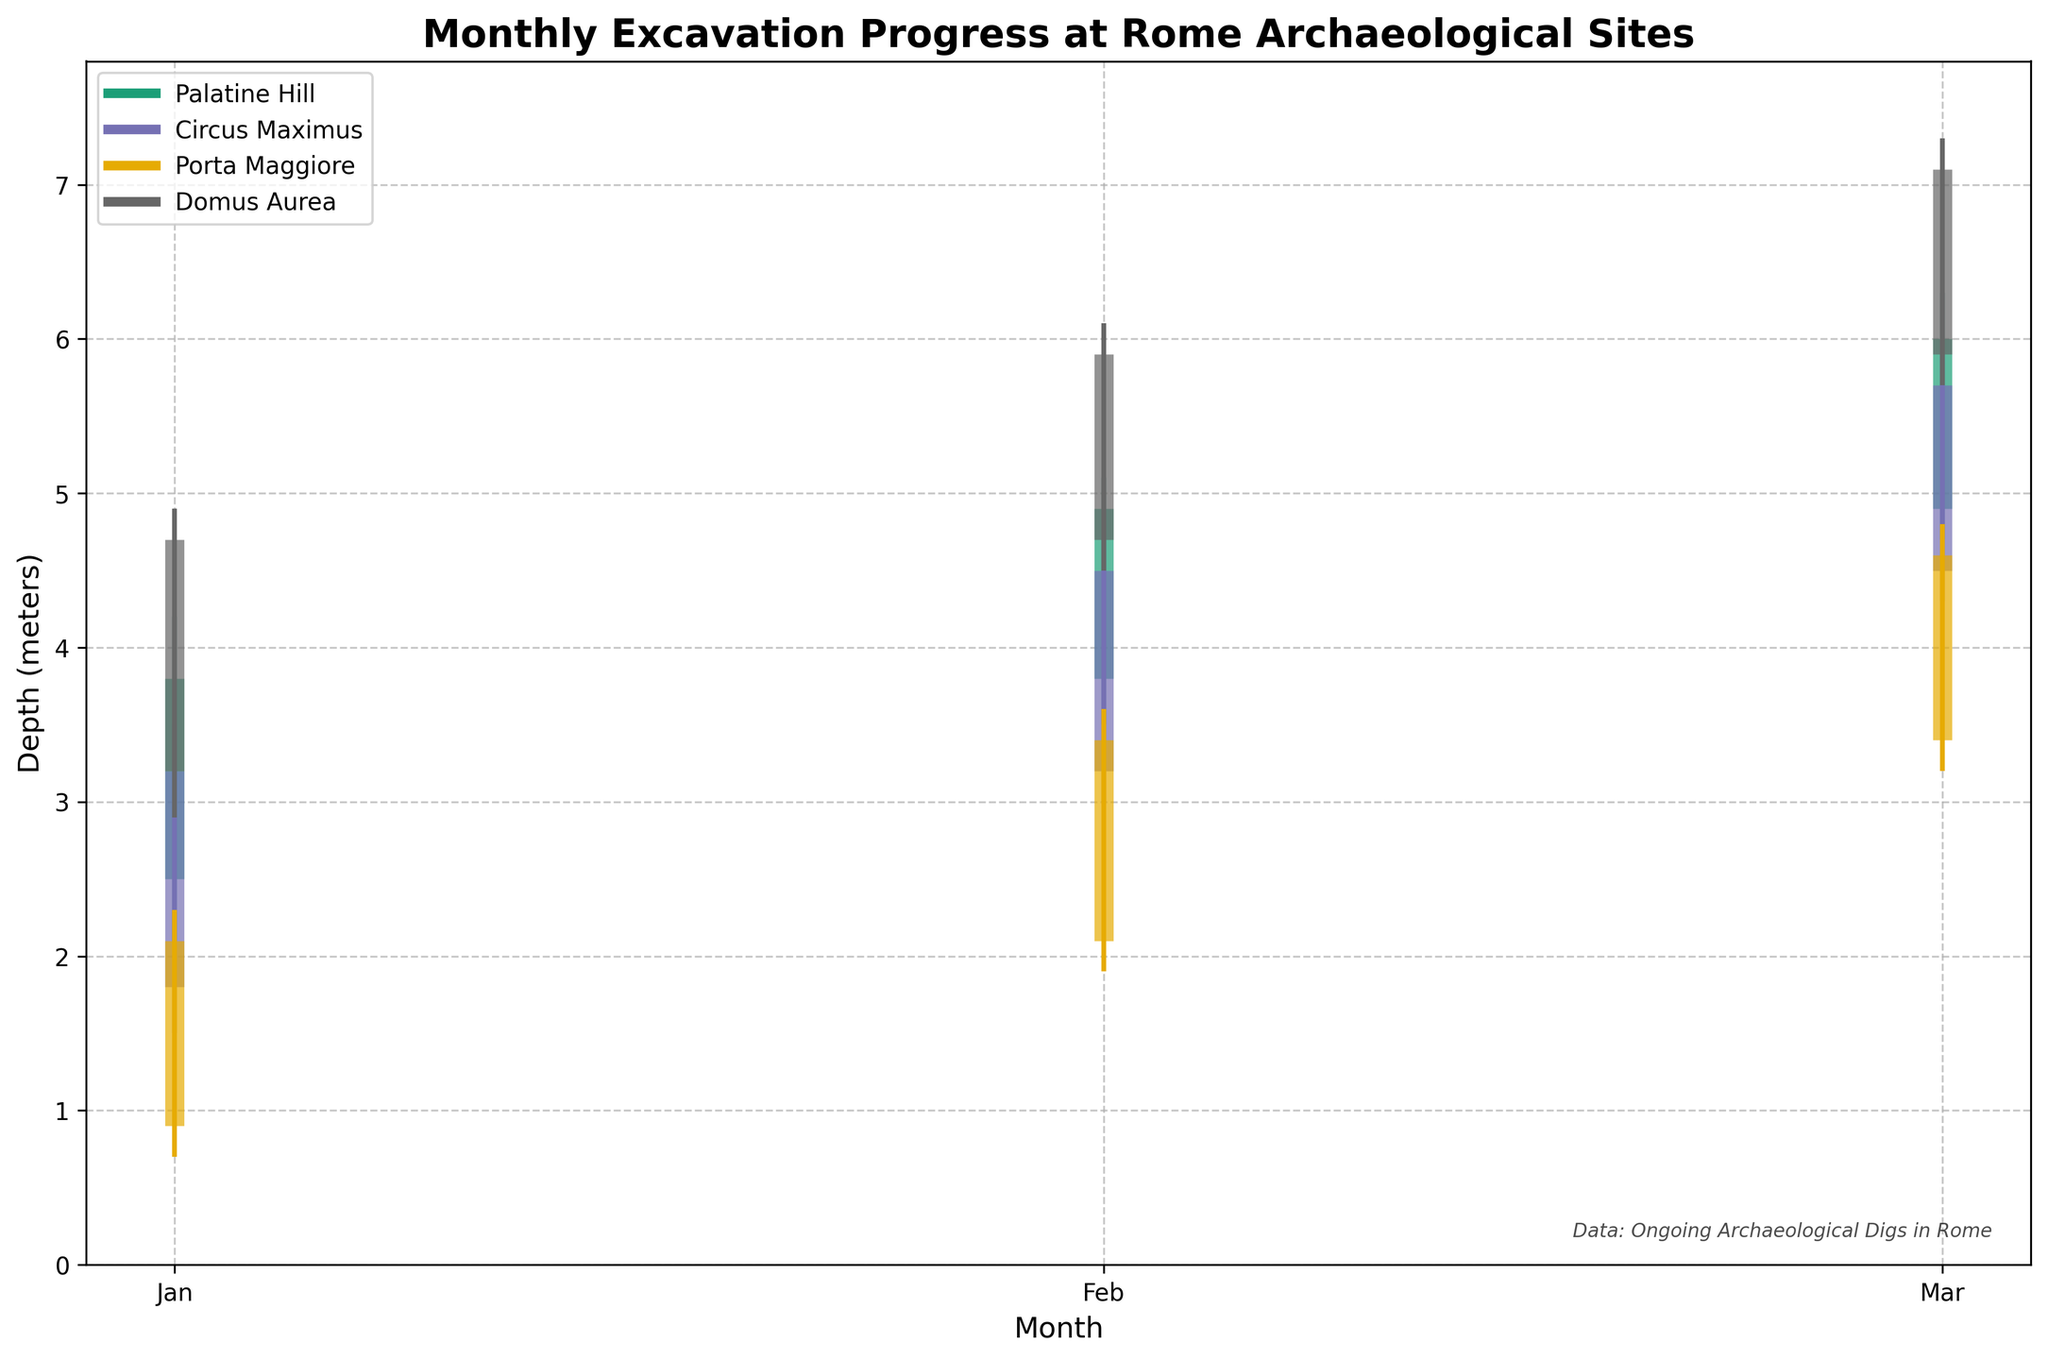What's the title of the plot? The title is usually displayed prominently at the top of the plot. The title of this plot is "Monthly Excavation Progress at Rome Archaeological Sites".
Answer: Monthly Excavation Progress at Rome Archaeological Sites What does the x-axis represent? The x-axis typically represents a variable that changes over time or across different categories. In this plot, the x-axis represents the months of the year.
Answer: Months What does the y-axis represent? The y-axis usually represents the variable being measured. In this plot, the y-axis represents depth in meters.
Answer: Depth (meters) Which site reached the maximum depth in March? To find this, examine the plot lines for March and identify the site with the highest point on the y-axis. Domus Aurea reached the maximum depth of 7.3 meters in March.
Answer: Domus Aurea In January, which site had the shallowest minimum depth explored? Look at the plot lines for January and identify the site with the lowest minimum depth point. Porta Maggiore had the shallowest minimum depth of 0.7 meters in January.
Answer: Porta Maggiore What was the final depth for Circus Maximus in February? Locate the February data point for Circus Maximus and look for the final depth, represented by the wider vertical bar. The final depth for Circus Maximus in February was 4.5 meters.
Answer: 4.5 meters Compare the initial depths in January for all sites. Which site had the deepest initial depth? Identify the initial depths (starting points of the lines) for January for each site. Domus Aurea had the deepest initial depth of 3.2 meters in January.
Answer: Domus Aurea Which month did Palatine Hill see the largest increase in final depth compared to the previous month? Calculate the difference in final depth between consecutive months for Palatine Hill and find the maximum increase. The largest increase is from January to February (3.8 to 4.9, an increase of 1.1 meters).
Answer: February On average, which site had the deepest minimum depth across all months? Calculate the average of the minimum depths for each site across all months and compare. Palatine Hill has the average minimum depth of (2.1 + 3.5 + 4.7) / 3 ≈ 3.43 meters, which is the deepest among the sites.
Answer: Palatine Hill Between Porta Maggiore and Domus Aurea, which site showed the most consistent (least variable) maximum depth across the three months? Examine the maximum depths for both sites across the months. Calculate the variance: Porta Maggiore (2.3, 3.6, 4.8) variance is around 0.568, Domus Aurea (4.9, 6.1, 7.3) variance is around 0.656. Porta Maggiore showed less variance and thus is more consistent.
Answer: Porta Maggiore 